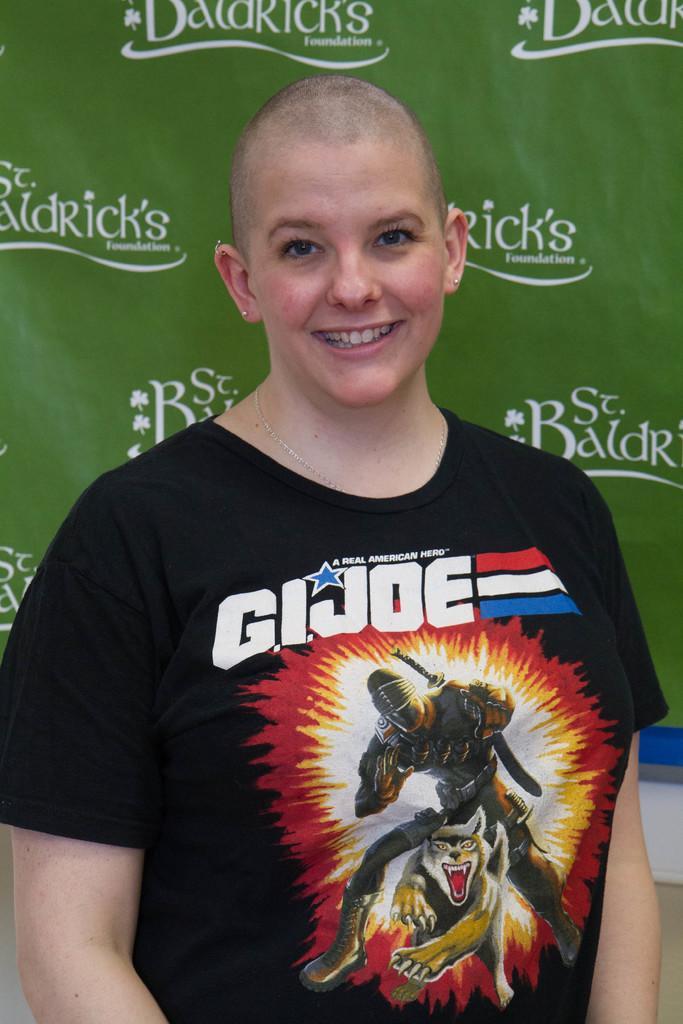Can you describe this image briefly? In this image we can see a woman smiling and an advertisement in the background. 